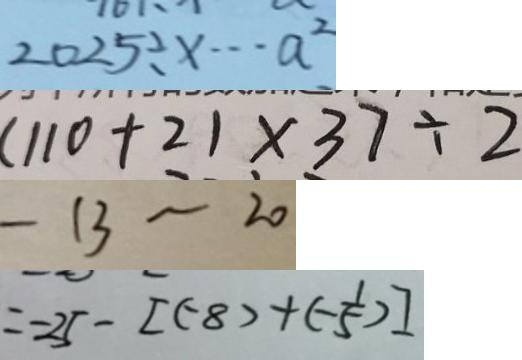<formula> <loc_0><loc_0><loc_500><loc_500>2 0 2 5 \div x \cdots a ^ { 2 } 
 ( 1 1 0 + 2 ) \times 3 7 \div 2 
 - 1 3 \sim 2 0 
 = - 2 5 - [ ( - 8 ) + ( - \frac { 1 } { 5 } ) ]</formula> 